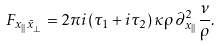Convert formula to latex. <formula><loc_0><loc_0><loc_500><loc_500>F _ { x _ { | | } \bar { x } _ { \perp } } = 2 \pi i ( \tau _ { 1 } + i \tau _ { 2 } ) \, \kappa \rho \, \partial _ { x _ { | | } } ^ { 2 } \frac { \nu } { \rho } .</formula> 